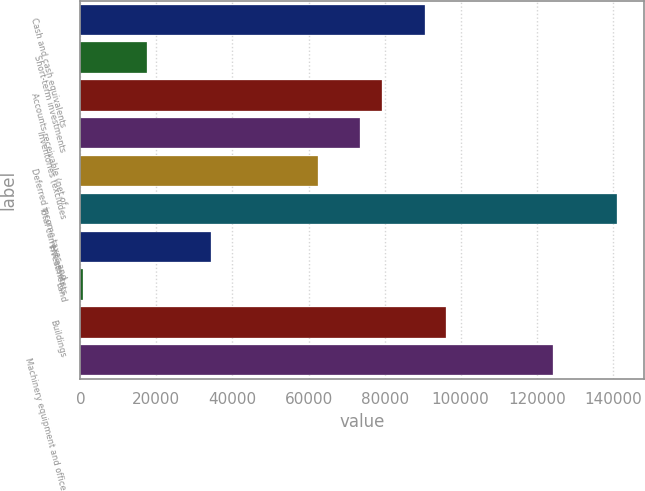Convert chart. <chart><loc_0><loc_0><loc_500><loc_500><bar_chart><fcel>Cash and cash equivalents<fcel>Short-term investments<fcel>Accounts receivable (net of<fcel>Inventories (excludes<fcel>Deferred income taxes and<fcel>Total current assets<fcel>Investments<fcel>Land<fcel>Buildings<fcel>Machinery equipment and office<nl><fcel>90493.2<fcel>17502.1<fcel>79263.8<fcel>73649.1<fcel>62419.7<fcel>141026<fcel>34346.2<fcel>658<fcel>96107.9<fcel>124181<nl></chart> 